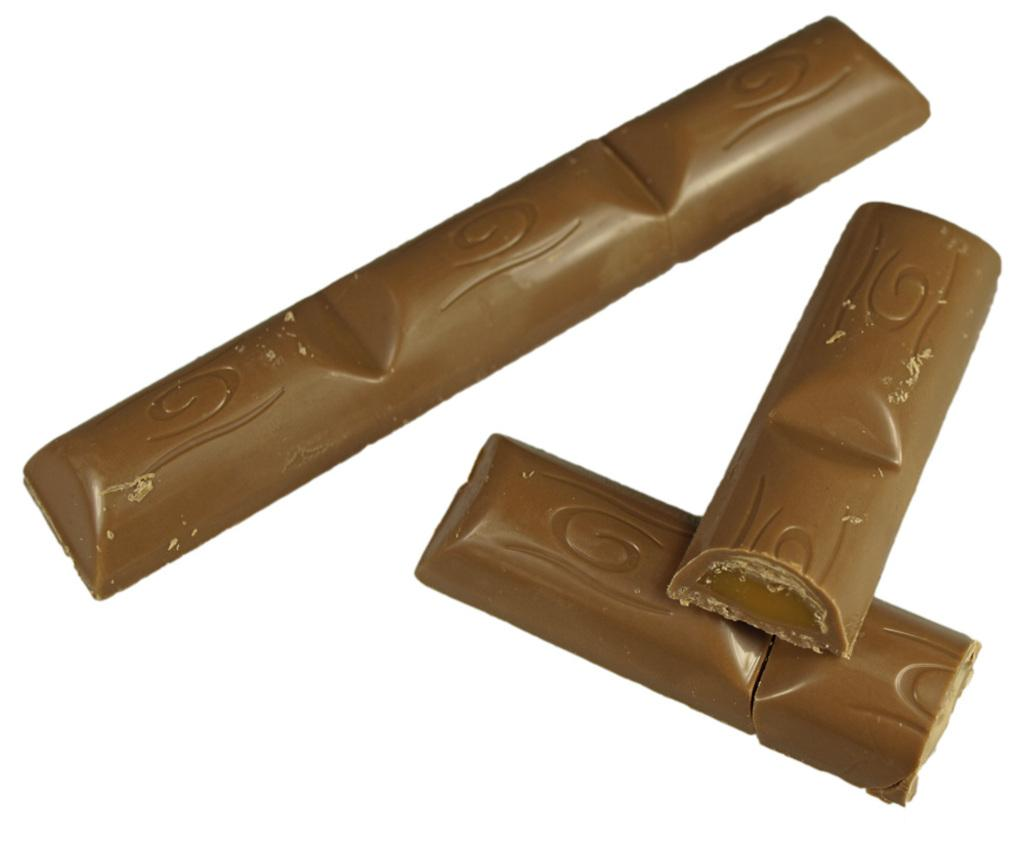What is the main subject of the image? The main subject of the image is a chocolate. What color is the chocolate? The chocolate is brown in color. What color is the background of the image? The background of the image is white. What type of wine is being served in the image? There is no wine present in the image; it features a chocolate. In which direction is the chocolate facing in the image? The chocolate is a stationary object and does not have a specific direction it is facing in the image. 